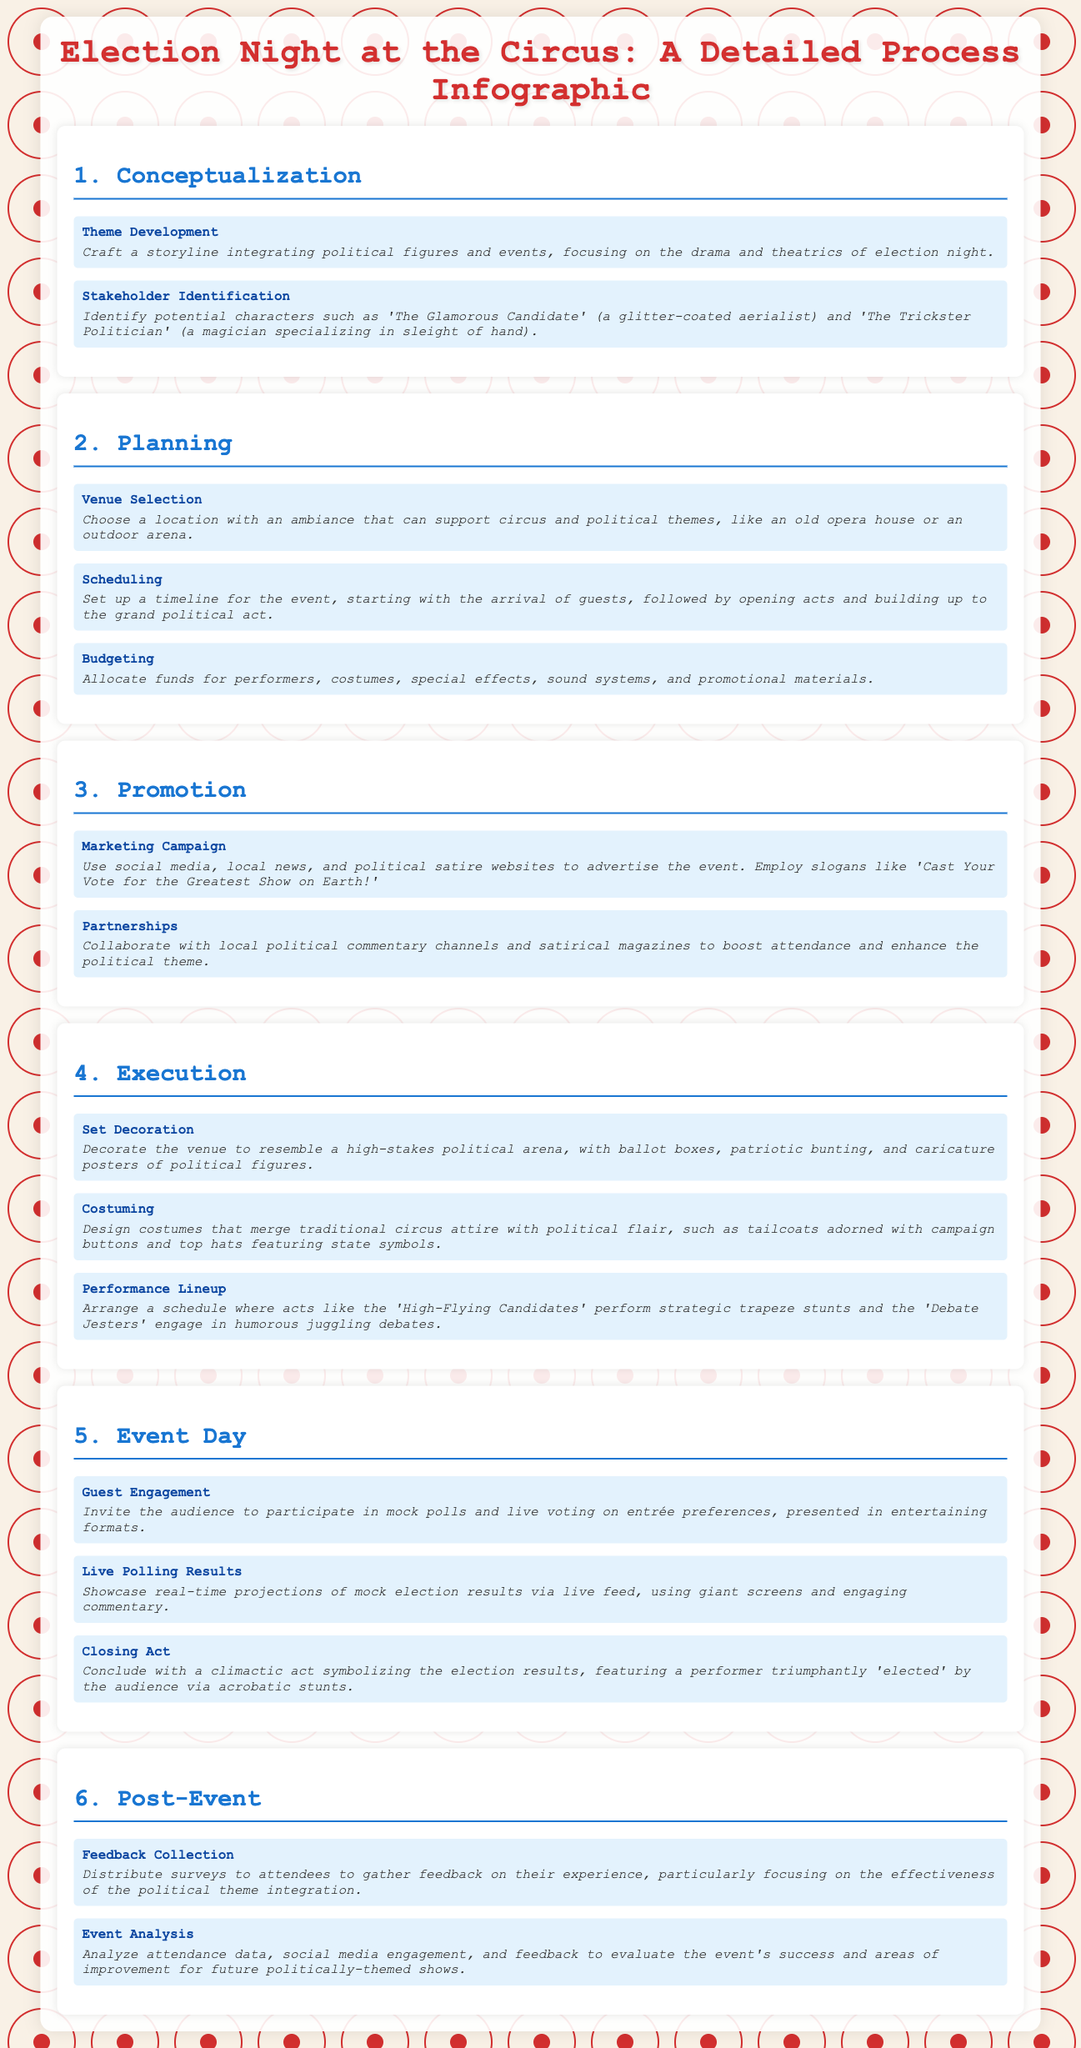What is the first stage of the event planning process? The first stage of the event planning process is mentioned as "Conceptualization" in the infographic.
Answer: Conceptualization Who is described as a character in the stakeholder identification? In the stakeholder identification, "The Glamorous Candidate" is identified as a character.
Answer: The Glamorous Candidate What venue type is suggested for selection? The document suggests selecting an "old opera house" or "outdoor arena" as a venue type.
Answer: Old opera house or outdoor arena What is the purpose of the marketing campaign? The marketing campaign aims to advertise the event using various platforms to boost attendance.
Answer: Advertise the event What decorative elements are suggested for the event? The document mentions using "ballot boxes," "patriotic bunting," and "caricature posters" for decoration.
Answer: Ballot boxes, patriotic bunting, caricature posters How are audience members engaged during the event day? Audience members are engaged by inviting them to participate in "mock polls" and "live voting."
Answer: Mock polls and live voting What type of feedback is collected post-event? Feedback collected post-event focuses on the effectiveness of the "political theme integration."
Answer: Political theme integration What aspect of the event is analyzed after its completion? After the event, "attendance data," "social media engagement," and "feedback" are analyzed.
Answer: Attendance data, social media engagement, feedback 